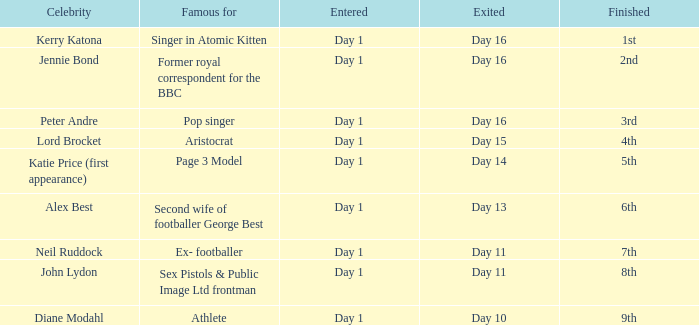Who is the well-known individual for their work as a page 3 model? Day 1. 